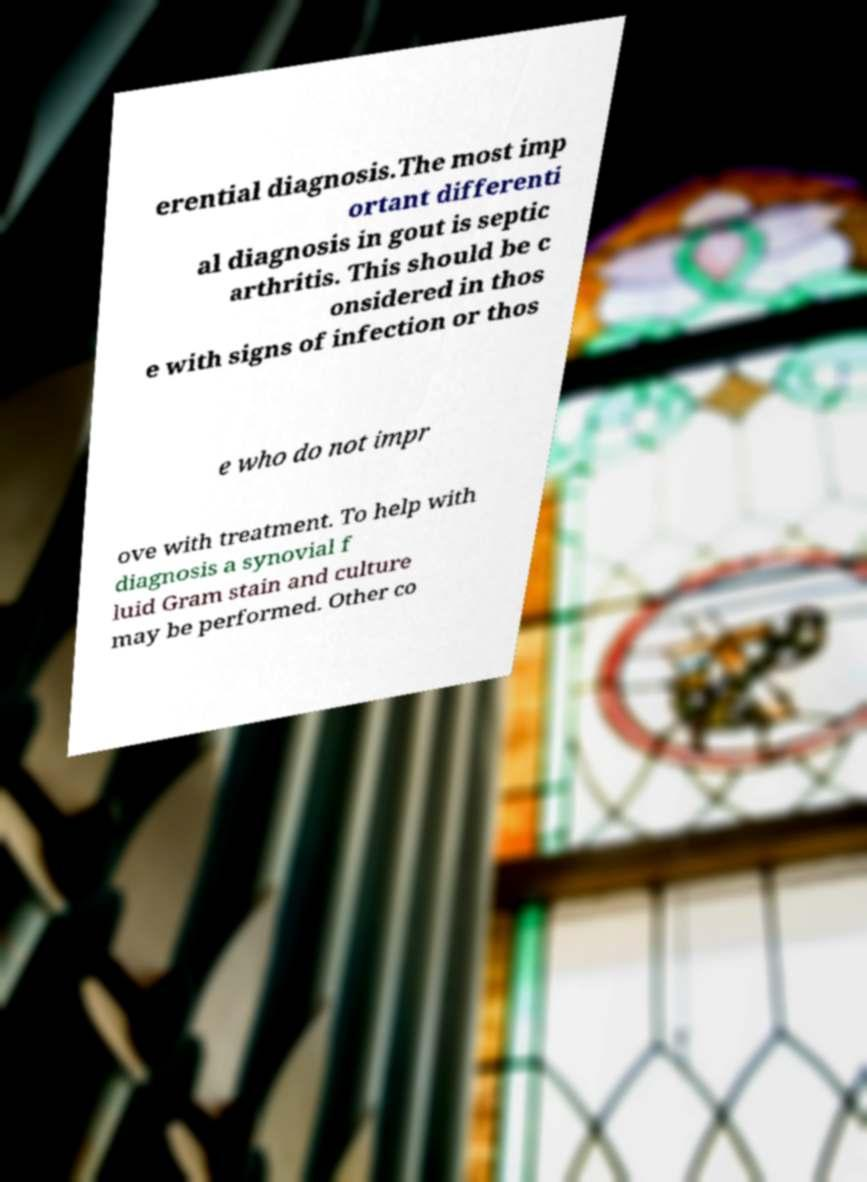Can you read and provide the text displayed in the image?This photo seems to have some interesting text. Can you extract and type it out for me? erential diagnosis.The most imp ortant differenti al diagnosis in gout is septic arthritis. This should be c onsidered in thos e with signs of infection or thos e who do not impr ove with treatment. To help with diagnosis a synovial f luid Gram stain and culture may be performed. Other co 